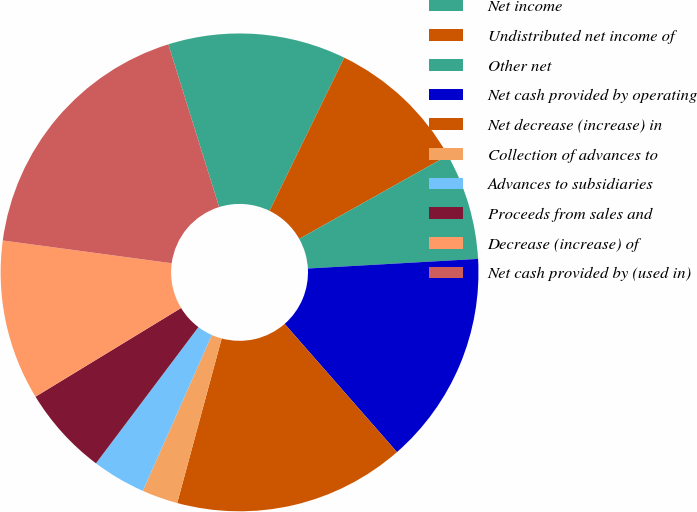Convert chart. <chart><loc_0><loc_0><loc_500><loc_500><pie_chart><fcel>Net income<fcel>Undistributed net income of<fcel>Other net<fcel>Net cash provided by operating<fcel>Net decrease (increase) in<fcel>Collection of advances to<fcel>Advances to subsidiaries<fcel>Proceeds from sales and<fcel>Decrease (increase) of<fcel>Net cash provided by (used in)<nl><fcel>12.04%<fcel>9.64%<fcel>7.24%<fcel>14.45%<fcel>15.65%<fcel>2.43%<fcel>3.63%<fcel>6.03%<fcel>10.84%<fcel>18.05%<nl></chart> 